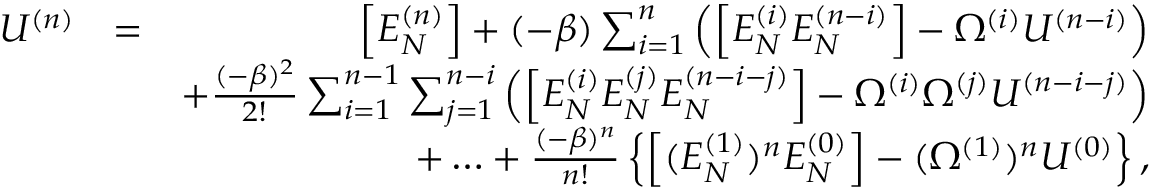<formula> <loc_0><loc_0><loc_500><loc_500>\begin{array} { r l r } { U ^ { ( n ) } } & { = } & { \left [ { E _ { N } ^ { ( n ) } } \right ] + ( - \beta ) \sum _ { i = 1 } ^ { n } \left ( \left [ E _ { N } ^ { ( i ) } E _ { N } ^ { ( n - i ) } \right ] - \Omega ^ { ( i ) } U ^ { ( n - i ) } \right ) } \\ & { + \frac { ( - \beta ) ^ { 2 } } { 2 ! } \sum _ { i = 1 } ^ { n - 1 } \sum _ { j = 1 } ^ { n - i } \left ( \left [ E _ { N } ^ { ( i ) } E _ { N } ^ { ( j ) } E _ { N } ^ { ( n - i - j ) } \right ] - \Omega ^ { ( i ) } \Omega ^ { ( j ) } U ^ { ( n - i - j ) } \right ) } \\ & { + \dots + \frac { ( - \beta ) ^ { n } } { n ! } \left \{ \left [ ( E _ { N } ^ { ( 1 ) } ) ^ { n } E _ { N } ^ { ( 0 ) } \right ] - ( \Omega ^ { ( 1 ) } ) ^ { n } U ^ { ( 0 ) } \right \} , } \end{array}</formula> 